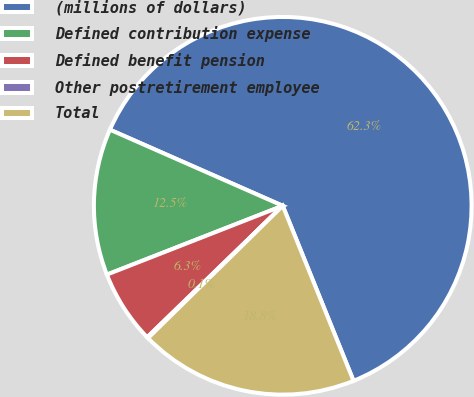Convert chart to OTSL. <chart><loc_0><loc_0><loc_500><loc_500><pie_chart><fcel>(millions of dollars)<fcel>Defined contribution expense<fcel>Defined benefit pension<fcel>Other postretirement employee<fcel>Total<nl><fcel>62.28%<fcel>12.54%<fcel>6.32%<fcel>0.1%<fcel>18.76%<nl></chart> 